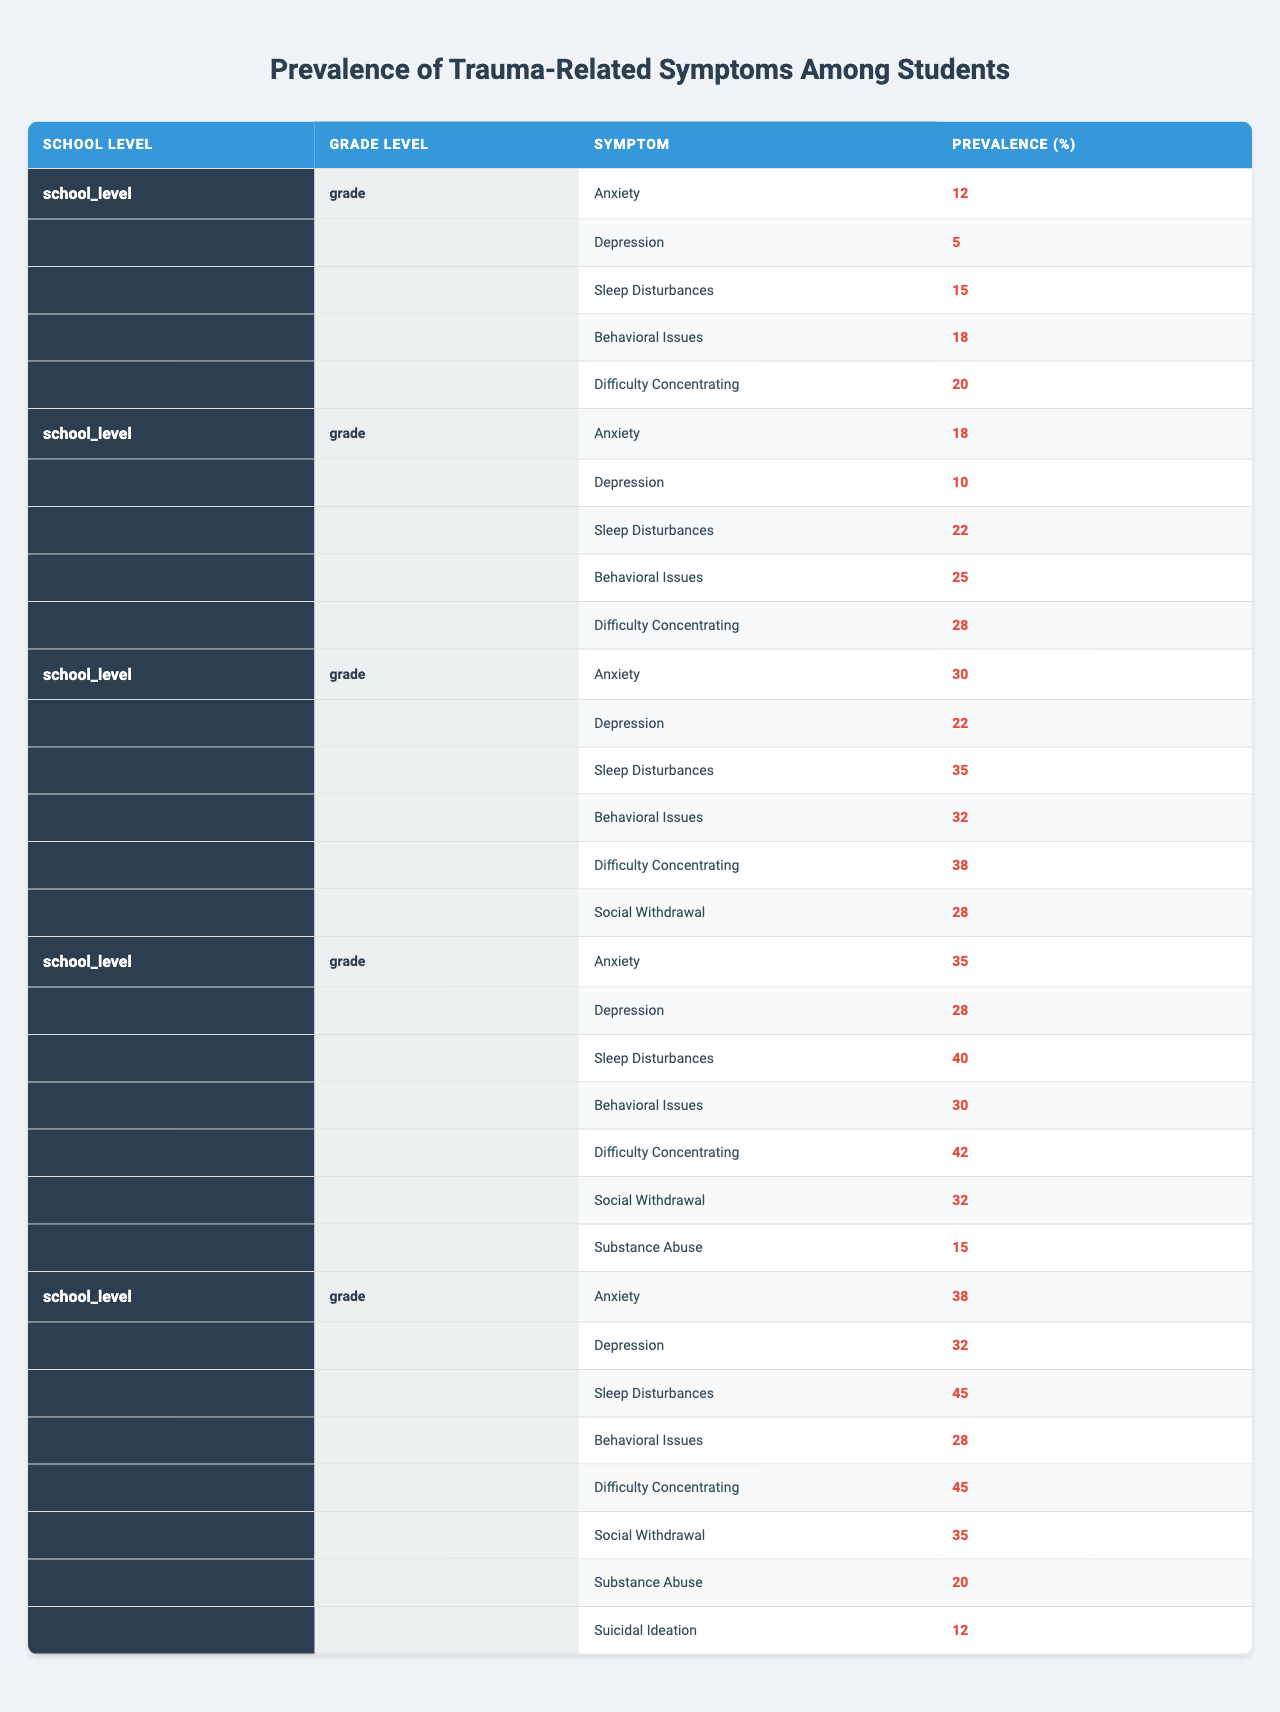What is the prevalence of anxiety symptoms in Grades 6-8? From the table, the prevalence of anxiety for Grades 6-8 under Middle School is listed as 30%.
Answer: 30% Which grade level has the highest prevalence of sleep disturbances? Looking through each section, Grades 11-12 in High School has the highest prevalence of sleep disturbances at 45%.
Answer: Grades 11-12 What is the total prevalence of behavioral issues across all grade levels in elementary school? In the table, Grades K-2 has 18% and Grades 3-5 has 25%, adding them gives 18 + 25 = 43%.
Answer: 43% Is depression more prevalent in high school compared to middle school? For high school, Grades 9-10 has 28% and Grades 11-12 has 32%. Middle School has 22%. Since both Grades in high school (28% and 32%) are greater than the middle school's 22%, it is true that depression is more prevalent in high school.
Answer: Yes What is the difference in prevalence of social withdrawal between Grades 6-8 and Grades 11-12? For Grades 6-8, social withdrawal is 28%, and for Grades 11-12 it is 35%. The difference is 35 - 28 = 7%.
Answer: 7% What is the average prevalence of difficulty concentrating among all grade levels? Adding the data: Grades K-2 has 20%, Grades 3-5 has 28%, Grades 6-8 has 38%, Grades 9-10 has 42%, and Grades 11-12 has 45%. This totals to 20 + 28 + 38 + 42 + 45 = 173%. Dividing by 5 gives an average of 173 / 5 = 34.6%.
Answer: 34.6% Which grade level shows the lowest percentage of depressive symptoms? Checking the table, the lowest percentage of depressive symptoms is found in Grades K-2 at 5%.
Answer: Grades K-2 In which grade levels is substance abuse not reported? Substance abuse is reported only in Grades 9-10 (15%) and Grades 11-12 (20%). Grades K-2, Grades 3-5, and Grades 6-8 show no reported substance abuse, indicating it is not reported in those levels.
Answer: K-2, 3-5, 6-8 If we sum the prevalence of anxiety for Grades 9-10 and 11-12, what is the total? The prevalence of anxiety for Grades 9-10 is 35% and for Grades 11-12 is 38%. The total is 35 + 38 = 73%.
Answer: 73% Which school level has the highest prevalence of behavioral issues? Across the table, Grades 3-5 in Elementary School has 25% behavioral issues, while Middle School has 32%, and High School has 30% (Grades 9-10). Middle School has the highest at 32%.
Answer: Middle School 